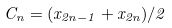Convert formula to latex. <formula><loc_0><loc_0><loc_500><loc_500>C _ { n } = ( x _ { 2 n - 1 } + x _ { 2 n } ) / 2</formula> 